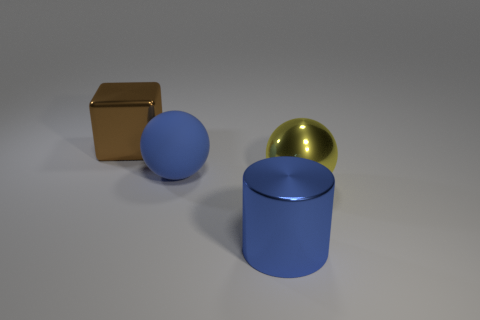Does the large block behind the yellow metal sphere have the same material as the large object that is in front of the big yellow thing?
Your answer should be very brief. Yes. The large matte object is what shape?
Offer a terse response. Sphere. Is the number of rubber spheres that are on the left side of the big yellow sphere greater than the number of large blue cylinders that are behind the blue rubber sphere?
Ensure brevity in your answer.  Yes. Do the yellow shiny object in front of the blue ball and the blue thing behind the large shiny cylinder have the same shape?
Ensure brevity in your answer.  Yes. How many other things are there of the same size as the brown cube?
Your response must be concise. 3. Is the block that is behind the big blue metal cylinder made of the same material as the blue sphere?
Offer a very short reply. No. What is the color of the other large object that is the same shape as the large blue matte thing?
Give a very brief answer. Yellow. There is a large ball that is on the left side of the big metallic cylinder; does it have the same color as the shiny cylinder?
Your answer should be very brief. Yes. Are there any large yellow spheres on the left side of the yellow metallic object?
Your response must be concise. No. The large thing that is behind the large yellow metallic thing and right of the large brown block is what color?
Your answer should be very brief. Blue. 